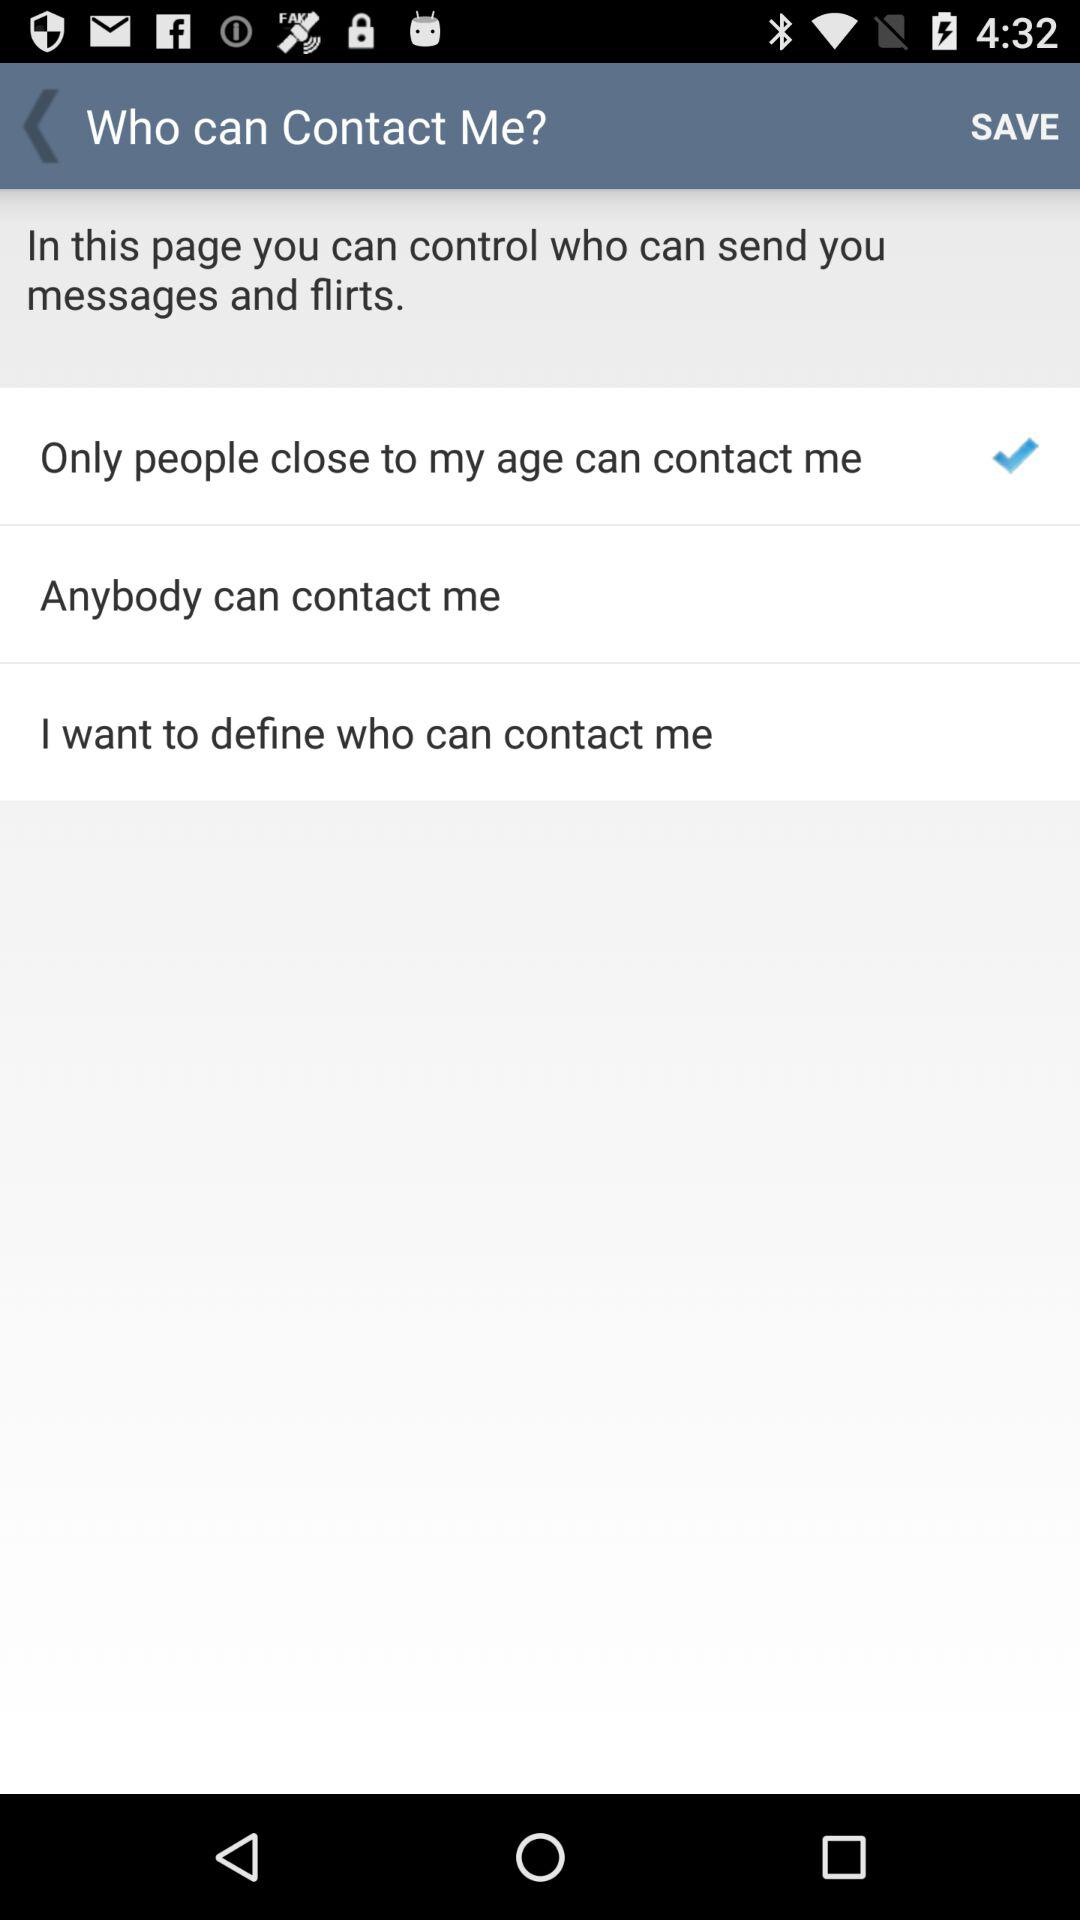Which option is selected for "In this page you can control who can send you messages and flirts."? The selected option is "Only people close to my age can contact me". 